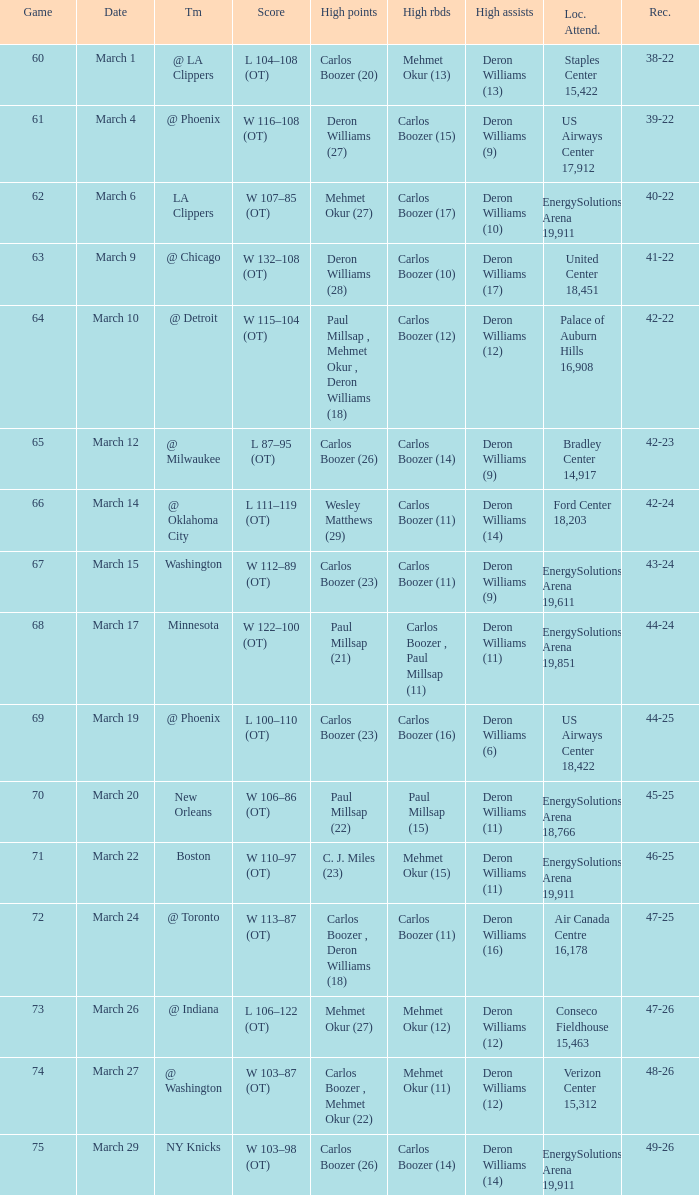How many players did the most high points in the game with 39-22 record? 1.0. 